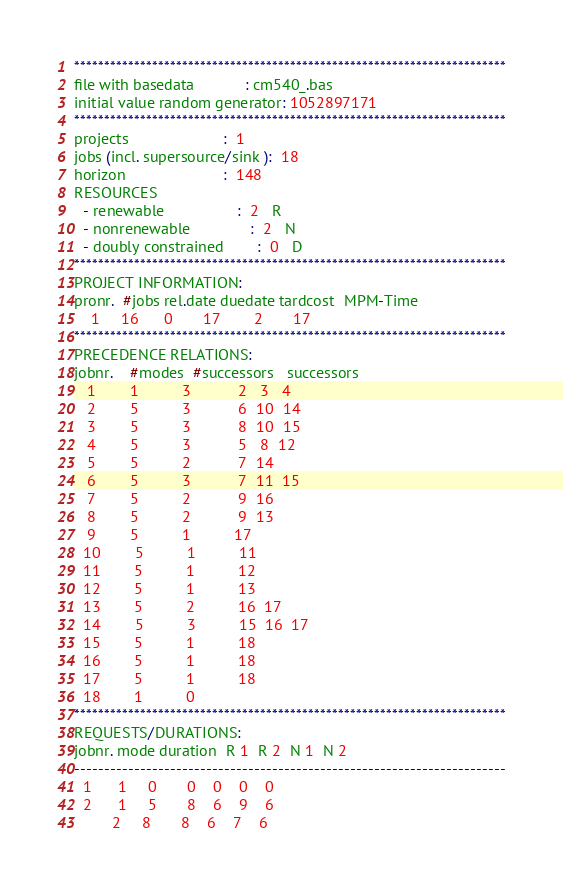Convert code to text. <code><loc_0><loc_0><loc_500><loc_500><_ObjectiveC_>************************************************************************
file with basedata            : cm540_.bas
initial value random generator: 1052897171
************************************************************************
projects                      :  1
jobs (incl. supersource/sink ):  18
horizon                       :  148
RESOURCES
  - renewable                 :  2   R
  - nonrenewable              :  2   N
  - doubly constrained        :  0   D
************************************************************************
PROJECT INFORMATION:
pronr.  #jobs rel.date duedate tardcost  MPM-Time
    1     16      0       17        2       17
************************************************************************
PRECEDENCE RELATIONS:
jobnr.    #modes  #successors   successors
   1        1          3           2   3   4
   2        5          3           6  10  14
   3        5          3           8  10  15
   4        5          3           5   8  12
   5        5          2           7  14
   6        5          3           7  11  15
   7        5          2           9  16
   8        5          2           9  13
   9        5          1          17
  10        5          1          11
  11        5          1          12
  12        5          1          13
  13        5          2          16  17
  14        5          3          15  16  17
  15        5          1          18
  16        5          1          18
  17        5          1          18
  18        1          0        
************************************************************************
REQUESTS/DURATIONS:
jobnr. mode duration  R 1  R 2  N 1  N 2
------------------------------------------------------------------------
  1      1     0       0    0    0    0
  2      1     5       8    6    9    6
         2     8       8    6    7    6</code> 